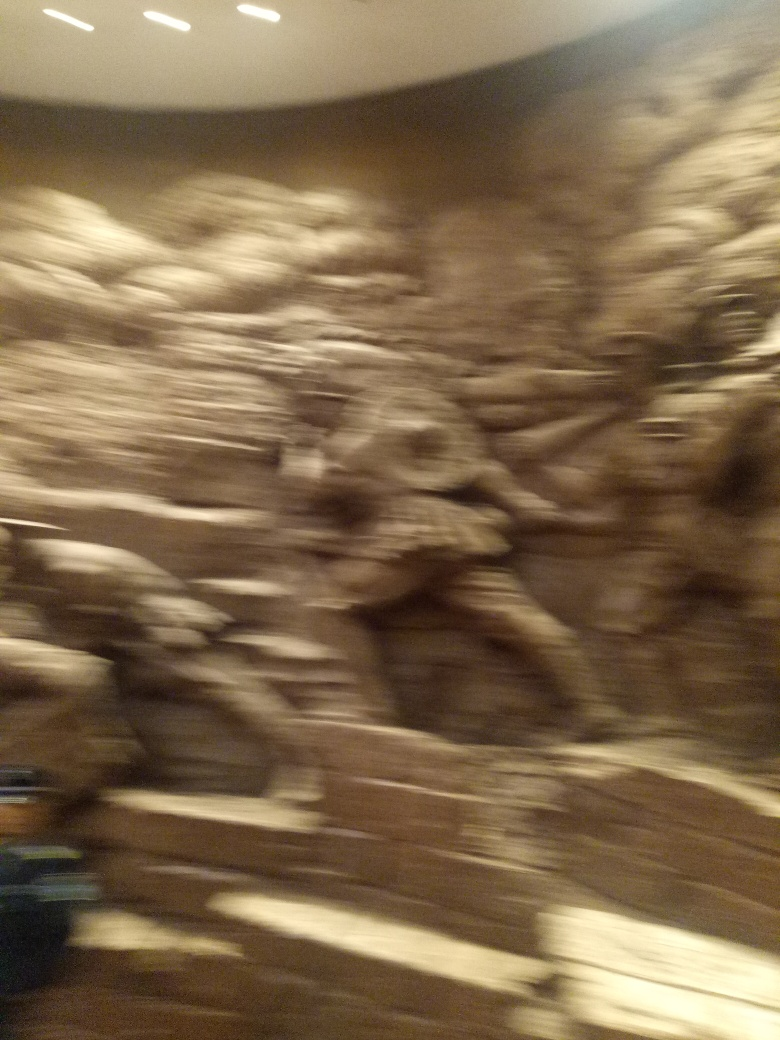Is there any distortion in the image? Option B (No) is selected, indicating that the image should be free of distortion. However, upon closer inspection, it is clear that the image does exhibit noticeable blur and distortion, which suggests that the conditions or settings under which the photo was taken may have led to a loss of sharpness and detail. Various factors, such as camera shake, a slow shutter speed, or an out-of-focus lens, could have contributed to this result. Therefore, a more accurate assessment would point out that there is indeed visible distortion in the image. 